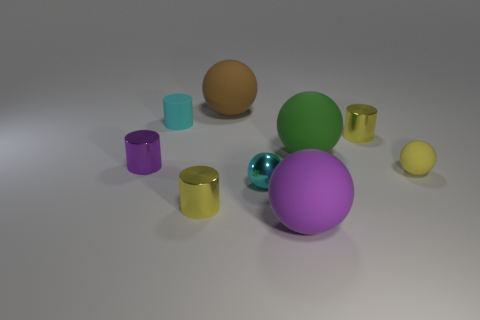How many spheres are there in total, and can you describe their colors? In the image, there are five spheres of different sizes and colors. Starting from the left and moving right, the colors are cyan, orange, green, a lavender or purple one in the center, and a small yellow sphere. 